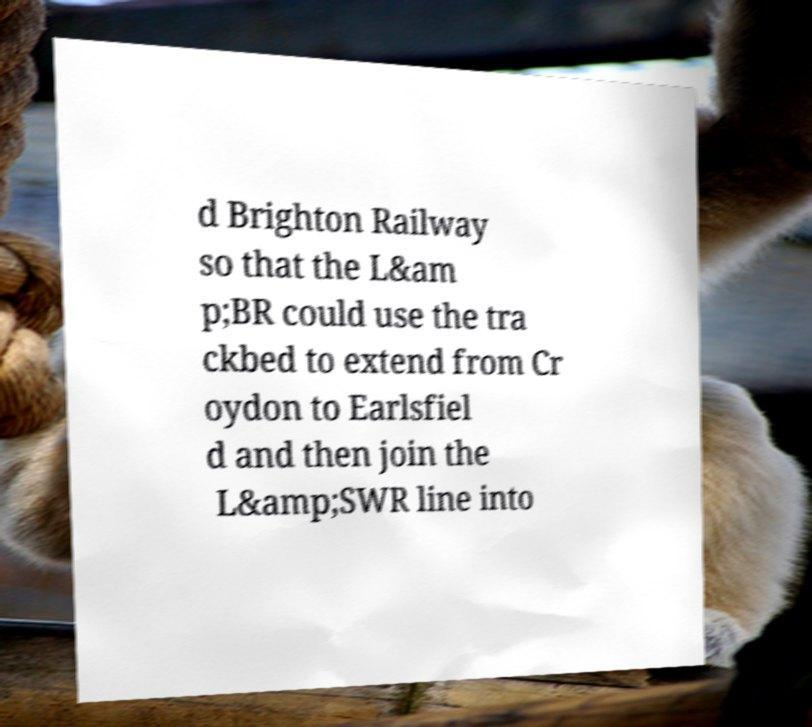Please read and relay the text visible in this image. What does it say? d Brighton Railway so that the L&am p;BR could use the tra ckbed to extend from Cr oydon to Earlsfiel d and then join the L&amp;SWR line into 